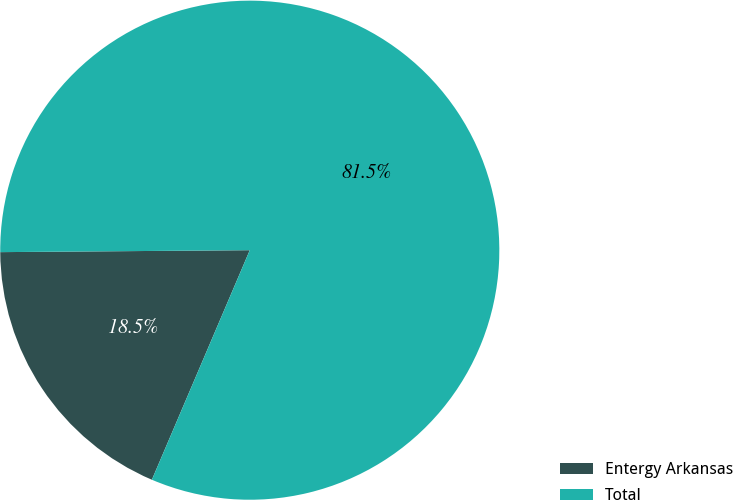<chart> <loc_0><loc_0><loc_500><loc_500><pie_chart><fcel>Entergy Arkansas<fcel>Total<nl><fcel>18.46%<fcel>81.54%<nl></chart> 